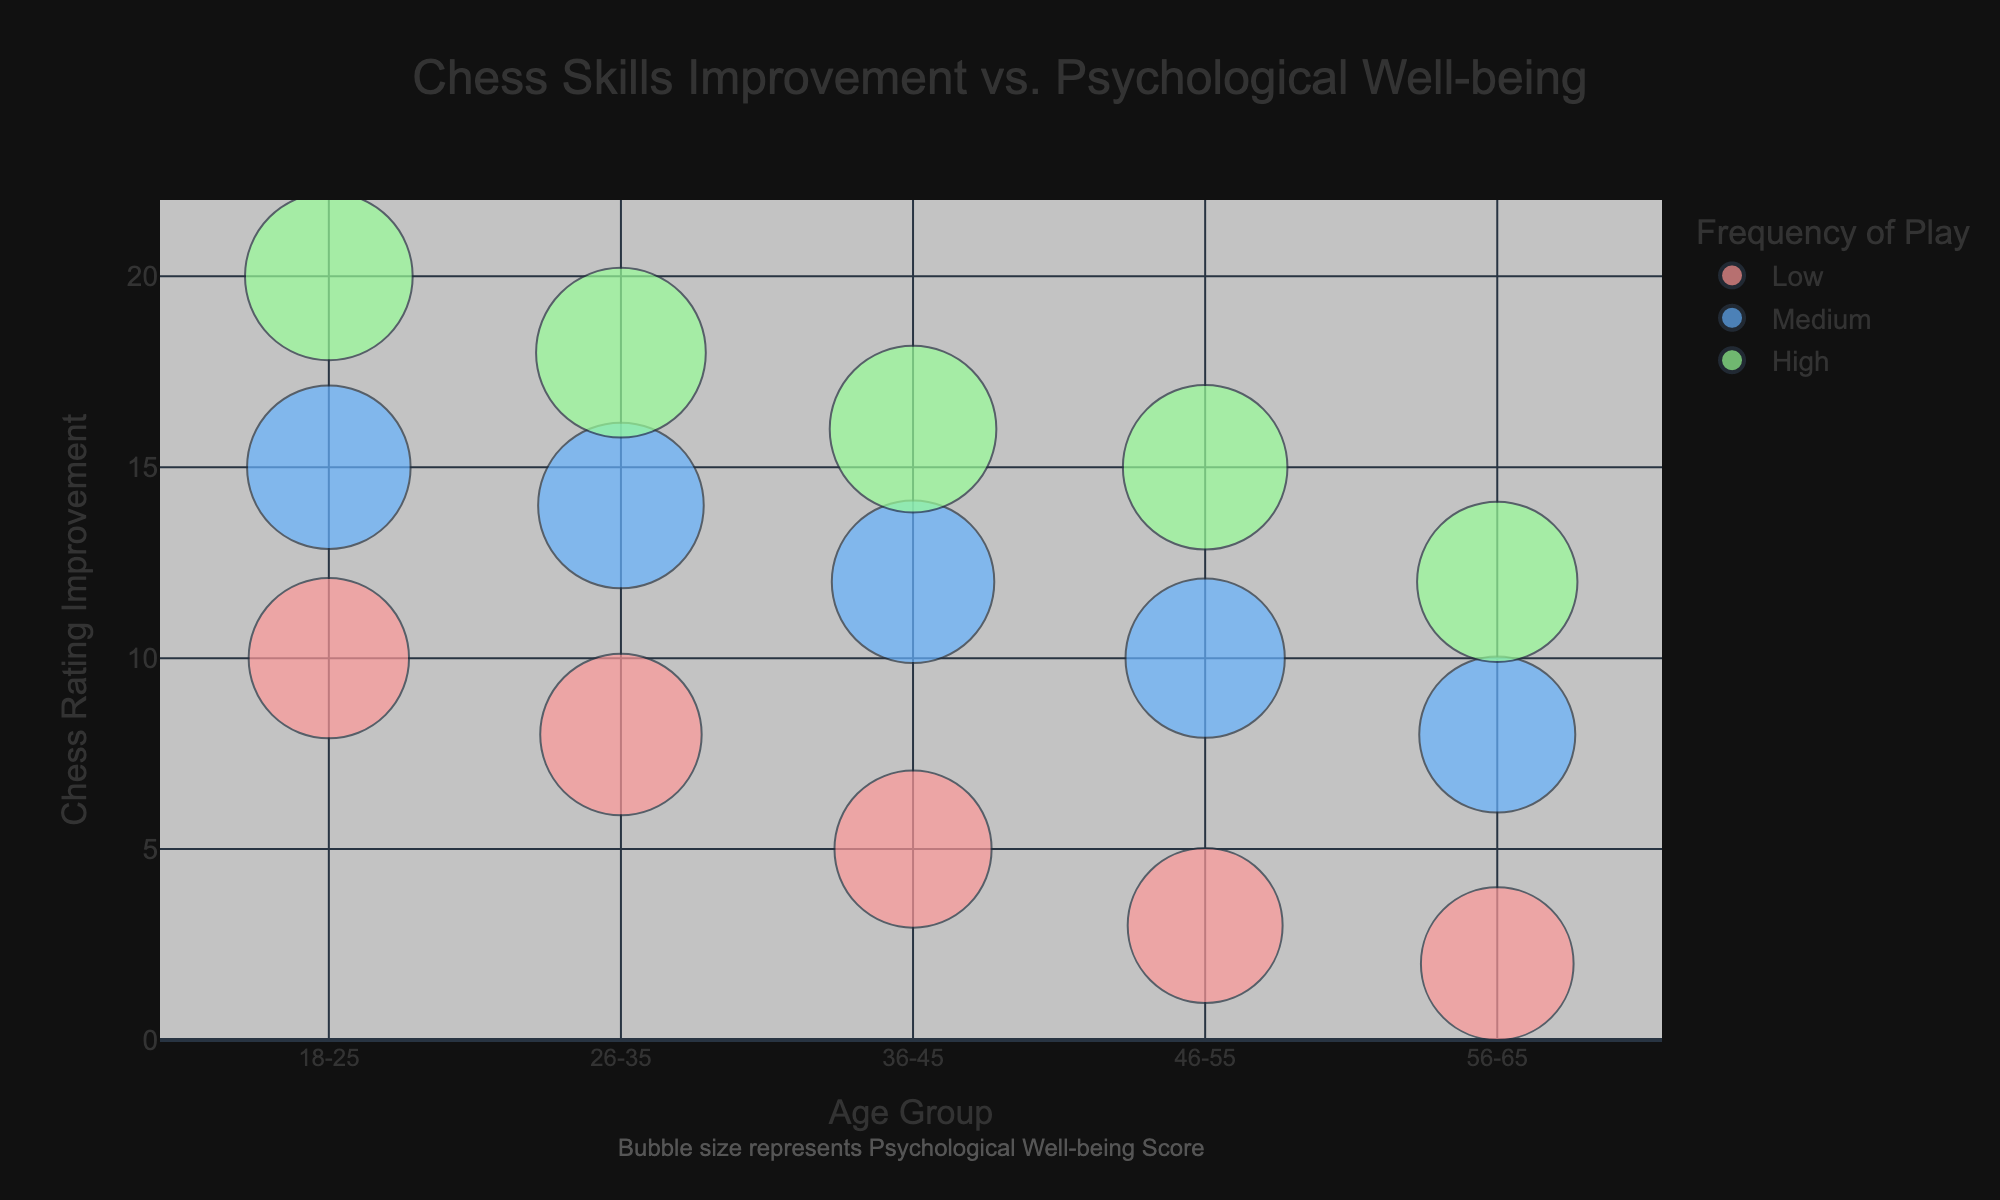What is the title of the chart? The title is typically displayed at the top of the chart in a larger and bold font.
Answer: Chess Skills Improvement vs. Psychological Well-being How are the frequency of play categories visually distinguished in the chart? The frequency of play categories "Low," "Medium," and "High" are distinguished by different colors for the bubbles.
Answer: Different colors Which age group has the highest chess rating improvement with high frequency of play? By identifying the highest y-value (Chess Rating Improvement) within the "High" frequency of play category for each age group, it shows that the 18-25 age group has the highest improvement.
Answer: 18-25 In the age group 46-55, what is the range of the psychological well-being scores for the different frequencies of play? The range is calculated based on the smallest and largest bubble sizes within the 46-55 age group. The scores go from 70 (Low) to 79 (High).
Answer: 70 to 79 What trend in psychological well-being scores can be observed across different frequencies of play for the age group 26-35? By comparing the size of bubbles for different frequencies of play within the 26-35 age group, it can be observed that as the frequency of play increases from Low to High, the psychological well-being score increases.
Answer: Increase with higher frequency Which age group has the lowest psychological well-being score for medium frequency of play? By examining the size of the bubbles within the "Medium" frequency of play category for each age group, it can be observed that the 56-65 age group has the lowest score (71).
Answer: 56-65 How does the chess rating improvement for the 36-45 age group with medium frequency of play compare to that of the 46-55 age group with high frequency of play? For 36-45 with medium frequency, the chess rating improvement is 12, while for 46-55 with high frequency, it is 15. Comparing these two values shows that the latter is higher.
Answer: 46-55 age group with high frequency has higher improvement What is the general trend in chess rating improvement across different age groups? By looking at the y-axis values across different age groups, there is a general trend where chess rating improvement tends to decrease with increasing age.
Answer: Decrease with age What is the average psychological well-being score for the high frequency of play category across all age groups? First, gather the well-being scores for high frequency: 82, 84, 81, 79, 75. Adding these gives 401, and dividing by the count (5) gives the average.
Answer: 80.2 